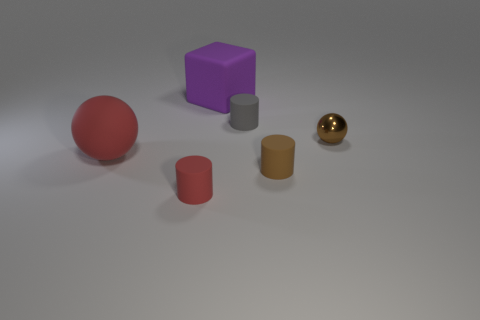Add 1 brown metal cylinders. How many objects exist? 7 Subtract all cubes. How many objects are left? 5 Add 1 purple blocks. How many purple blocks exist? 2 Subtract 0 red blocks. How many objects are left? 6 Subtract all large purple things. Subtract all big red matte things. How many objects are left? 4 Add 1 red cylinders. How many red cylinders are left? 2 